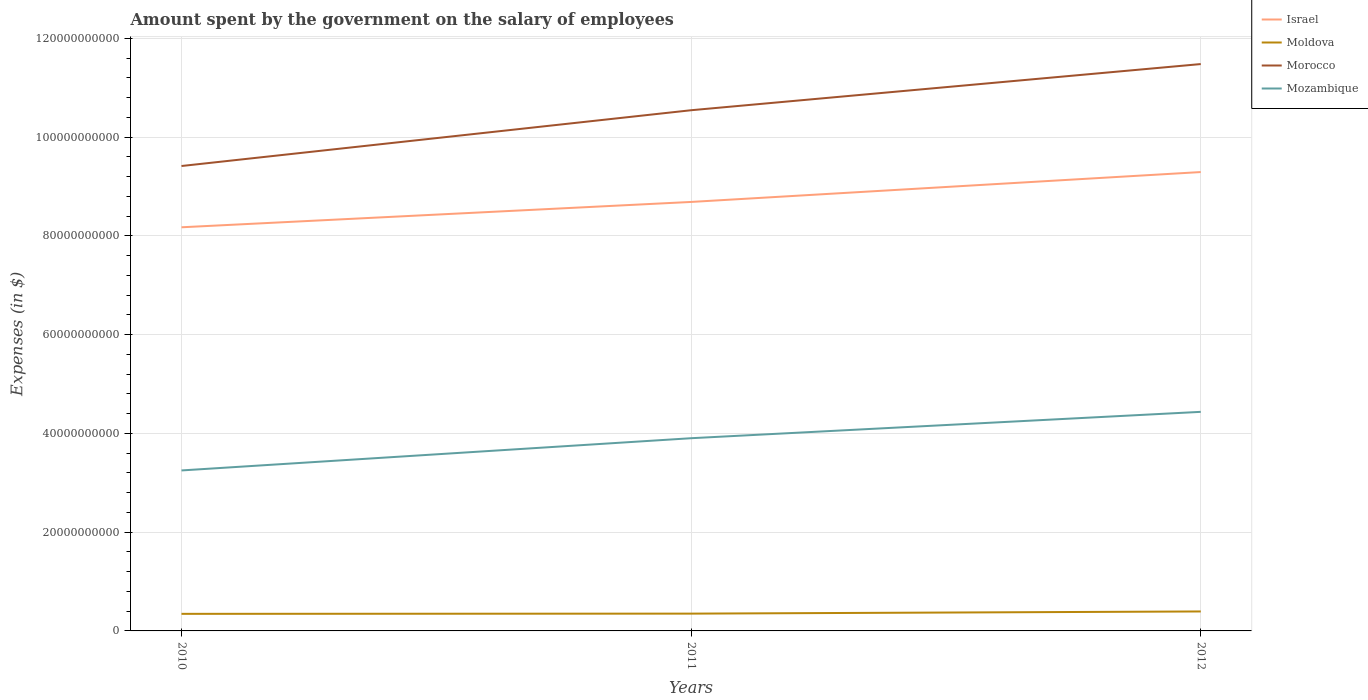How many different coloured lines are there?
Your answer should be very brief. 4. Across all years, what is the maximum amount spent on the salary of employees by the government in Israel?
Provide a short and direct response. 8.18e+1. What is the total amount spent on the salary of employees by the government in Israel in the graph?
Make the answer very short. -6.05e+09. What is the difference between the highest and the second highest amount spent on the salary of employees by the government in Mozambique?
Offer a very short reply. 1.19e+1. What is the difference between the highest and the lowest amount spent on the salary of employees by the government in Mozambique?
Provide a succinct answer. 2. Are the values on the major ticks of Y-axis written in scientific E-notation?
Ensure brevity in your answer.  No. Does the graph contain grids?
Provide a succinct answer. Yes. Where does the legend appear in the graph?
Provide a succinct answer. Top right. How many legend labels are there?
Your answer should be compact. 4. What is the title of the graph?
Your answer should be compact. Amount spent by the government on the salary of employees. Does "Senegal" appear as one of the legend labels in the graph?
Make the answer very short. No. What is the label or title of the Y-axis?
Provide a succinct answer. Expenses (in $). What is the Expenses (in $) in Israel in 2010?
Ensure brevity in your answer.  8.18e+1. What is the Expenses (in $) of Moldova in 2010?
Keep it short and to the point. 3.46e+09. What is the Expenses (in $) in Morocco in 2010?
Give a very brief answer. 9.42e+1. What is the Expenses (in $) of Mozambique in 2010?
Provide a short and direct response. 3.25e+1. What is the Expenses (in $) in Israel in 2011?
Offer a very short reply. 8.69e+1. What is the Expenses (in $) in Moldova in 2011?
Your answer should be compact. 3.50e+09. What is the Expenses (in $) of Morocco in 2011?
Keep it short and to the point. 1.05e+11. What is the Expenses (in $) in Mozambique in 2011?
Offer a terse response. 3.90e+1. What is the Expenses (in $) in Israel in 2012?
Ensure brevity in your answer.  9.29e+1. What is the Expenses (in $) of Moldova in 2012?
Offer a very short reply. 3.94e+09. What is the Expenses (in $) of Morocco in 2012?
Your response must be concise. 1.15e+11. What is the Expenses (in $) in Mozambique in 2012?
Your response must be concise. 4.44e+1. Across all years, what is the maximum Expenses (in $) in Israel?
Provide a short and direct response. 9.29e+1. Across all years, what is the maximum Expenses (in $) of Moldova?
Provide a short and direct response. 3.94e+09. Across all years, what is the maximum Expenses (in $) in Morocco?
Give a very brief answer. 1.15e+11. Across all years, what is the maximum Expenses (in $) in Mozambique?
Keep it short and to the point. 4.44e+1. Across all years, what is the minimum Expenses (in $) in Israel?
Provide a succinct answer. 8.18e+1. Across all years, what is the minimum Expenses (in $) in Moldova?
Your answer should be very brief. 3.46e+09. Across all years, what is the minimum Expenses (in $) in Morocco?
Offer a very short reply. 9.42e+1. Across all years, what is the minimum Expenses (in $) in Mozambique?
Offer a terse response. 3.25e+1. What is the total Expenses (in $) of Israel in the graph?
Your response must be concise. 2.62e+11. What is the total Expenses (in $) of Moldova in the graph?
Provide a succinct answer. 1.09e+1. What is the total Expenses (in $) of Morocco in the graph?
Ensure brevity in your answer.  3.14e+11. What is the total Expenses (in $) of Mozambique in the graph?
Provide a succinct answer. 1.16e+11. What is the difference between the Expenses (in $) in Israel in 2010 and that in 2011?
Your response must be concise. -5.13e+09. What is the difference between the Expenses (in $) in Moldova in 2010 and that in 2011?
Your answer should be very brief. -4.29e+07. What is the difference between the Expenses (in $) in Morocco in 2010 and that in 2011?
Offer a very short reply. -1.13e+1. What is the difference between the Expenses (in $) in Mozambique in 2010 and that in 2011?
Your answer should be very brief. -6.53e+09. What is the difference between the Expenses (in $) in Israel in 2010 and that in 2012?
Keep it short and to the point. -1.12e+1. What is the difference between the Expenses (in $) in Moldova in 2010 and that in 2012?
Offer a very short reply. -4.85e+08. What is the difference between the Expenses (in $) of Morocco in 2010 and that in 2012?
Offer a very short reply. -2.06e+1. What is the difference between the Expenses (in $) in Mozambique in 2010 and that in 2012?
Your answer should be compact. -1.19e+1. What is the difference between the Expenses (in $) in Israel in 2011 and that in 2012?
Give a very brief answer. -6.05e+09. What is the difference between the Expenses (in $) in Moldova in 2011 and that in 2012?
Offer a terse response. -4.42e+08. What is the difference between the Expenses (in $) of Morocco in 2011 and that in 2012?
Give a very brief answer. -9.35e+09. What is the difference between the Expenses (in $) in Mozambique in 2011 and that in 2012?
Provide a succinct answer. -5.34e+09. What is the difference between the Expenses (in $) in Israel in 2010 and the Expenses (in $) in Moldova in 2011?
Offer a very short reply. 7.83e+1. What is the difference between the Expenses (in $) in Israel in 2010 and the Expenses (in $) in Morocco in 2011?
Offer a terse response. -2.37e+1. What is the difference between the Expenses (in $) in Israel in 2010 and the Expenses (in $) in Mozambique in 2011?
Ensure brevity in your answer.  4.27e+1. What is the difference between the Expenses (in $) of Moldova in 2010 and the Expenses (in $) of Morocco in 2011?
Provide a succinct answer. -1.02e+11. What is the difference between the Expenses (in $) of Moldova in 2010 and the Expenses (in $) of Mozambique in 2011?
Provide a succinct answer. -3.56e+1. What is the difference between the Expenses (in $) of Morocco in 2010 and the Expenses (in $) of Mozambique in 2011?
Give a very brief answer. 5.51e+1. What is the difference between the Expenses (in $) of Israel in 2010 and the Expenses (in $) of Moldova in 2012?
Your answer should be very brief. 7.78e+1. What is the difference between the Expenses (in $) in Israel in 2010 and the Expenses (in $) in Morocco in 2012?
Your response must be concise. -3.31e+1. What is the difference between the Expenses (in $) in Israel in 2010 and the Expenses (in $) in Mozambique in 2012?
Make the answer very short. 3.74e+1. What is the difference between the Expenses (in $) in Moldova in 2010 and the Expenses (in $) in Morocco in 2012?
Offer a very short reply. -1.11e+11. What is the difference between the Expenses (in $) of Moldova in 2010 and the Expenses (in $) of Mozambique in 2012?
Offer a terse response. -4.09e+1. What is the difference between the Expenses (in $) of Morocco in 2010 and the Expenses (in $) of Mozambique in 2012?
Your answer should be very brief. 4.98e+1. What is the difference between the Expenses (in $) of Israel in 2011 and the Expenses (in $) of Moldova in 2012?
Make the answer very short. 8.29e+1. What is the difference between the Expenses (in $) of Israel in 2011 and the Expenses (in $) of Morocco in 2012?
Give a very brief answer. -2.79e+1. What is the difference between the Expenses (in $) in Israel in 2011 and the Expenses (in $) in Mozambique in 2012?
Offer a terse response. 4.25e+1. What is the difference between the Expenses (in $) in Moldova in 2011 and the Expenses (in $) in Morocco in 2012?
Provide a short and direct response. -1.11e+11. What is the difference between the Expenses (in $) in Moldova in 2011 and the Expenses (in $) in Mozambique in 2012?
Your answer should be very brief. -4.09e+1. What is the difference between the Expenses (in $) of Morocco in 2011 and the Expenses (in $) of Mozambique in 2012?
Your response must be concise. 6.11e+1. What is the average Expenses (in $) in Israel per year?
Your answer should be very brief. 8.72e+1. What is the average Expenses (in $) of Moldova per year?
Your answer should be compact. 3.63e+09. What is the average Expenses (in $) in Morocco per year?
Keep it short and to the point. 1.05e+11. What is the average Expenses (in $) of Mozambique per year?
Your answer should be compact. 3.86e+1. In the year 2010, what is the difference between the Expenses (in $) of Israel and Expenses (in $) of Moldova?
Your answer should be compact. 7.83e+1. In the year 2010, what is the difference between the Expenses (in $) in Israel and Expenses (in $) in Morocco?
Your response must be concise. -1.24e+1. In the year 2010, what is the difference between the Expenses (in $) of Israel and Expenses (in $) of Mozambique?
Offer a terse response. 4.93e+1. In the year 2010, what is the difference between the Expenses (in $) of Moldova and Expenses (in $) of Morocco?
Your answer should be very brief. -9.07e+1. In the year 2010, what is the difference between the Expenses (in $) of Moldova and Expenses (in $) of Mozambique?
Your answer should be compact. -2.90e+1. In the year 2010, what is the difference between the Expenses (in $) in Morocco and Expenses (in $) in Mozambique?
Your answer should be very brief. 6.17e+1. In the year 2011, what is the difference between the Expenses (in $) of Israel and Expenses (in $) of Moldova?
Your response must be concise. 8.34e+1. In the year 2011, what is the difference between the Expenses (in $) of Israel and Expenses (in $) of Morocco?
Make the answer very short. -1.86e+1. In the year 2011, what is the difference between the Expenses (in $) in Israel and Expenses (in $) in Mozambique?
Make the answer very short. 4.79e+1. In the year 2011, what is the difference between the Expenses (in $) of Moldova and Expenses (in $) of Morocco?
Offer a terse response. -1.02e+11. In the year 2011, what is the difference between the Expenses (in $) of Moldova and Expenses (in $) of Mozambique?
Give a very brief answer. -3.55e+1. In the year 2011, what is the difference between the Expenses (in $) in Morocco and Expenses (in $) in Mozambique?
Ensure brevity in your answer.  6.64e+1. In the year 2012, what is the difference between the Expenses (in $) in Israel and Expenses (in $) in Moldova?
Offer a very short reply. 8.90e+1. In the year 2012, what is the difference between the Expenses (in $) in Israel and Expenses (in $) in Morocco?
Give a very brief answer. -2.19e+1. In the year 2012, what is the difference between the Expenses (in $) of Israel and Expenses (in $) of Mozambique?
Offer a very short reply. 4.86e+1. In the year 2012, what is the difference between the Expenses (in $) in Moldova and Expenses (in $) in Morocco?
Your answer should be very brief. -1.11e+11. In the year 2012, what is the difference between the Expenses (in $) in Moldova and Expenses (in $) in Mozambique?
Offer a terse response. -4.04e+1. In the year 2012, what is the difference between the Expenses (in $) of Morocco and Expenses (in $) of Mozambique?
Give a very brief answer. 7.04e+1. What is the ratio of the Expenses (in $) of Israel in 2010 to that in 2011?
Offer a very short reply. 0.94. What is the ratio of the Expenses (in $) in Moldova in 2010 to that in 2011?
Your answer should be compact. 0.99. What is the ratio of the Expenses (in $) in Morocco in 2010 to that in 2011?
Ensure brevity in your answer.  0.89. What is the ratio of the Expenses (in $) in Mozambique in 2010 to that in 2011?
Your answer should be compact. 0.83. What is the ratio of the Expenses (in $) in Israel in 2010 to that in 2012?
Your answer should be very brief. 0.88. What is the ratio of the Expenses (in $) in Moldova in 2010 to that in 2012?
Offer a very short reply. 0.88. What is the ratio of the Expenses (in $) of Morocco in 2010 to that in 2012?
Provide a succinct answer. 0.82. What is the ratio of the Expenses (in $) in Mozambique in 2010 to that in 2012?
Offer a terse response. 0.73. What is the ratio of the Expenses (in $) of Israel in 2011 to that in 2012?
Make the answer very short. 0.93. What is the ratio of the Expenses (in $) of Moldova in 2011 to that in 2012?
Your response must be concise. 0.89. What is the ratio of the Expenses (in $) in Morocco in 2011 to that in 2012?
Give a very brief answer. 0.92. What is the ratio of the Expenses (in $) in Mozambique in 2011 to that in 2012?
Keep it short and to the point. 0.88. What is the difference between the highest and the second highest Expenses (in $) of Israel?
Provide a short and direct response. 6.05e+09. What is the difference between the highest and the second highest Expenses (in $) of Moldova?
Provide a short and direct response. 4.42e+08. What is the difference between the highest and the second highest Expenses (in $) in Morocco?
Offer a terse response. 9.35e+09. What is the difference between the highest and the second highest Expenses (in $) of Mozambique?
Your answer should be compact. 5.34e+09. What is the difference between the highest and the lowest Expenses (in $) of Israel?
Make the answer very short. 1.12e+1. What is the difference between the highest and the lowest Expenses (in $) of Moldova?
Your answer should be very brief. 4.85e+08. What is the difference between the highest and the lowest Expenses (in $) in Morocco?
Your answer should be very brief. 2.06e+1. What is the difference between the highest and the lowest Expenses (in $) in Mozambique?
Provide a short and direct response. 1.19e+1. 